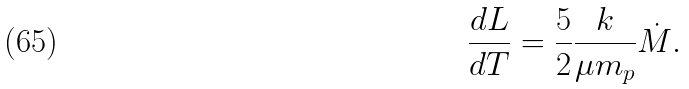Convert formula to latex. <formula><loc_0><loc_0><loc_500><loc_500>\frac { d L } { d T } = \frac { 5 } { 2 } \frac { k } { \mu m _ { p } } \dot { M } .</formula> 